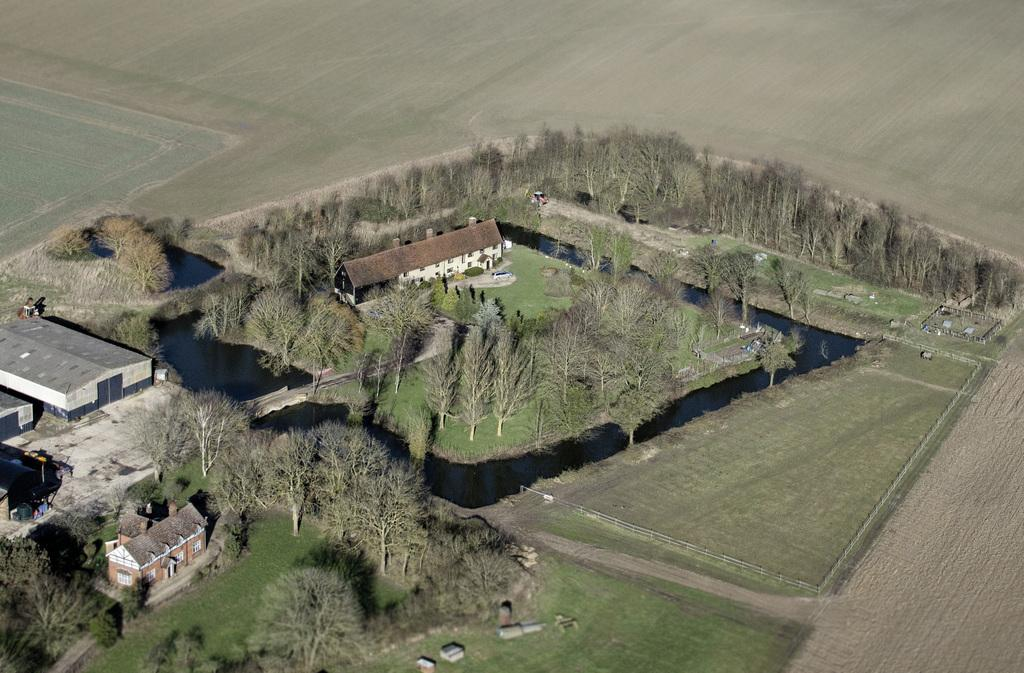What type of view is depicted in the image? The image is an aerial view. What type of vegetation can be seen in the image? There are trees visible in the image. What type of ground cover can be seen in the image? There is grass visible in the image. What type of man-made structures can be seen in the image? There are buildings visible in the image. What type of terrain is visible in the image? There is land visible in the image. Can you see any icicles hanging from the trees in the image? There are no icicles visible in the image; it is an aerial view of an area with trees, grass, buildings, and land. What type of animal can be seen grazing on the grass in the image? There are no animals visible in the image; it is an aerial view of an area with trees, grass, buildings, and land. 